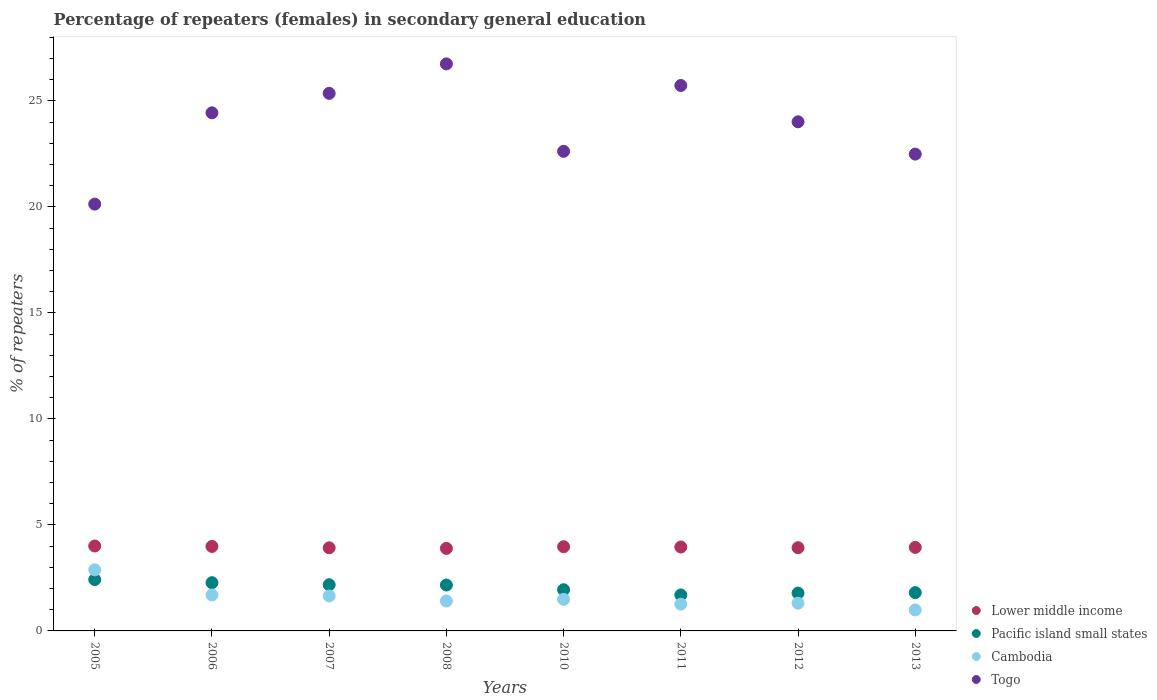How many different coloured dotlines are there?
Provide a short and direct response. 4. What is the percentage of female repeaters in Togo in 2011?
Keep it short and to the point. 25.73. Across all years, what is the maximum percentage of female repeaters in Lower middle income?
Make the answer very short. 4.01. Across all years, what is the minimum percentage of female repeaters in Pacific island small states?
Ensure brevity in your answer.  1.7. What is the total percentage of female repeaters in Lower middle income in the graph?
Your response must be concise. 31.6. What is the difference between the percentage of female repeaters in Togo in 2010 and that in 2011?
Provide a succinct answer. -3.11. What is the difference between the percentage of female repeaters in Cambodia in 2010 and the percentage of female repeaters in Lower middle income in 2012?
Your answer should be very brief. -2.44. What is the average percentage of female repeaters in Pacific island small states per year?
Your answer should be compact. 2.03. In the year 2012, what is the difference between the percentage of female repeaters in Togo and percentage of female repeaters in Pacific island small states?
Give a very brief answer. 22.23. In how many years, is the percentage of female repeaters in Pacific island small states greater than 27 %?
Your answer should be compact. 0. What is the ratio of the percentage of female repeaters in Pacific island small states in 2005 to that in 2010?
Ensure brevity in your answer.  1.25. Is the percentage of female repeaters in Togo in 2005 less than that in 2012?
Give a very brief answer. Yes. Is the difference between the percentage of female repeaters in Togo in 2005 and 2011 greater than the difference between the percentage of female repeaters in Pacific island small states in 2005 and 2011?
Offer a terse response. No. What is the difference between the highest and the second highest percentage of female repeaters in Pacific island small states?
Make the answer very short. 0.15. What is the difference between the highest and the lowest percentage of female repeaters in Lower middle income?
Make the answer very short. 0.11. In how many years, is the percentage of female repeaters in Cambodia greater than the average percentage of female repeaters in Cambodia taken over all years?
Offer a terse response. 3. Is the sum of the percentage of female repeaters in Pacific island small states in 2006 and 2011 greater than the maximum percentage of female repeaters in Cambodia across all years?
Your answer should be very brief. Yes. Is it the case that in every year, the sum of the percentage of female repeaters in Pacific island small states and percentage of female repeaters in Togo  is greater than the sum of percentage of female repeaters in Lower middle income and percentage of female repeaters in Cambodia?
Ensure brevity in your answer.  Yes. Is it the case that in every year, the sum of the percentage of female repeaters in Togo and percentage of female repeaters in Lower middle income  is greater than the percentage of female repeaters in Cambodia?
Provide a short and direct response. Yes. Is the percentage of female repeaters in Lower middle income strictly greater than the percentage of female repeaters in Togo over the years?
Give a very brief answer. No. Are the values on the major ticks of Y-axis written in scientific E-notation?
Your answer should be very brief. No. Does the graph contain any zero values?
Make the answer very short. No. How many legend labels are there?
Offer a very short reply. 4. How are the legend labels stacked?
Give a very brief answer. Vertical. What is the title of the graph?
Offer a very short reply. Percentage of repeaters (females) in secondary general education. What is the label or title of the X-axis?
Keep it short and to the point. Years. What is the label or title of the Y-axis?
Offer a very short reply. % of repeaters. What is the % of repeaters of Lower middle income in 2005?
Your response must be concise. 4.01. What is the % of repeaters of Pacific island small states in 2005?
Provide a short and direct response. 2.42. What is the % of repeaters in Cambodia in 2005?
Ensure brevity in your answer.  2.88. What is the % of repeaters in Togo in 2005?
Ensure brevity in your answer.  20.13. What is the % of repeaters of Lower middle income in 2006?
Your answer should be very brief. 3.99. What is the % of repeaters in Pacific island small states in 2006?
Your response must be concise. 2.28. What is the % of repeaters of Cambodia in 2006?
Offer a very short reply. 1.7. What is the % of repeaters of Togo in 2006?
Ensure brevity in your answer.  24.44. What is the % of repeaters of Lower middle income in 2007?
Your answer should be very brief. 3.92. What is the % of repeaters of Pacific island small states in 2007?
Provide a short and direct response. 2.18. What is the % of repeaters in Cambodia in 2007?
Keep it short and to the point. 1.65. What is the % of repeaters in Togo in 2007?
Provide a short and direct response. 25.36. What is the % of repeaters in Lower middle income in 2008?
Your answer should be very brief. 3.89. What is the % of repeaters in Pacific island small states in 2008?
Provide a succinct answer. 2.16. What is the % of repeaters in Cambodia in 2008?
Ensure brevity in your answer.  1.41. What is the % of repeaters in Togo in 2008?
Offer a terse response. 26.75. What is the % of repeaters in Lower middle income in 2010?
Your response must be concise. 3.97. What is the % of repeaters of Pacific island small states in 2010?
Ensure brevity in your answer.  1.94. What is the % of repeaters in Cambodia in 2010?
Your response must be concise. 1.49. What is the % of repeaters in Togo in 2010?
Your answer should be very brief. 22.62. What is the % of repeaters in Lower middle income in 2011?
Provide a succinct answer. 3.96. What is the % of repeaters of Pacific island small states in 2011?
Give a very brief answer. 1.7. What is the % of repeaters of Cambodia in 2011?
Provide a short and direct response. 1.26. What is the % of repeaters of Togo in 2011?
Your response must be concise. 25.73. What is the % of repeaters in Lower middle income in 2012?
Give a very brief answer. 3.93. What is the % of repeaters of Pacific island small states in 2012?
Your answer should be very brief. 1.79. What is the % of repeaters of Cambodia in 2012?
Make the answer very short. 1.31. What is the % of repeaters in Togo in 2012?
Offer a terse response. 24.02. What is the % of repeaters in Lower middle income in 2013?
Your response must be concise. 3.94. What is the % of repeaters in Pacific island small states in 2013?
Make the answer very short. 1.81. What is the % of repeaters of Cambodia in 2013?
Your answer should be compact. 0.99. What is the % of repeaters in Togo in 2013?
Provide a succinct answer. 22.49. Across all years, what is the maximum % of repeaters in Lower middle income?
Provide a short and direct response. 4.01. Across all years, what is the maximum % of repeaters of Pacific island small states?
Ensure brevity in your answer.  2.42. Across all years, what is the maximum % of repeaters of Cambodia?
Keep it short and to the point. 2.88. Across all years, what is the maximum % of repeaters of Togo?
Provide a succinct answer. 26.75. Across all years, what is the minimum % of repeaters in Lower middle income?
Offer a very short reply. 3.89. Across all years, what is the minimum % of repeaters in Pacific island small states?
Provide a short and direct response. 1.7. Across all years, what is the minimum % of repeaters of Cambodia?
Your response must be concise. 0.99. Across all years, what is the minimum % of repeaters of Togo?
Make the answer very short. 20.13. What is the total % of repeaters of Lower middle income in the graph?
Your response must be concise. 31.6. What is the total % of repeaters in Pacific island small states in the graph?
Offer a terse response. 16.27. What is the total % of repeaters of Cambodia in the graph?
Provide a short and direct response. 12.69. What is the total % of repeaters of Togo in the graph?
Offer a very short reply. 191.55. What is the difference between the % of repeaters in Lower middle income in 2005 and that in 2006?
Your response must be concise. 0.02. What is the difference between the % of repeaters in Pacific island small states in 2005 and that in 2006?
Offer a terse response. 0.15. What is the difference between the % of repeaters of Cambodia in 2005 and that in 2006?
Provide a short and direct response. 1.19. What is the difference between the % of repeaters in Togo in 2005 and that in 2006?
Your answer should be compact. -4.31. What is the difference between the % of repeaters of Lower middle income in 2005 and that in 2007?
Your response must be concise. 0.08. What is the difference between the % of repeaters in Pacific island small states in 2005 and that in 2007?
Provide a succinct answer. 0.24. What is the difference between the % of repeaters of Cambodia in 2005 and that in 2007?
Provide a succinct answer. 1.23. What is the difference between the % of repeaters of Togo in 2005 and that in 2007?
Offer a very short reply. -5.22. What is the difference between the % of repeaters in Lower middle income in 2005 and that in 2008?
Provide a short and direct response. 0.11. What is the difference between the % of repeaters in Pacific island small states in 2005 and that in 2008?
Make the answer very short. 0.26. What is the difference between the % of repeaters of Cambodia in 2005 and that in 2008?
Your answer should be very brief. 1.47. What is the difference between the % of repeaters in Togo in 2005 and that in 2008?
Make the answer very short. -6.61. What is the difference between the % of repeaters of Lower middle income in 2005 and that in 2010?
Provide a succinct answer. 0.03. What is the difference between the % of repeaters in Pacific island small states in 2005 and that in 2010?
Your response must be concise. 0.48. What is the difference between the % of repeaters of Cambodia in 2005 and that in 2010?
Ensure brevity in your answer.  1.39. What is the difference between the % of repeaters of Togo in 2005 and that in 2010?
Ensure brevity in your answer.  -2.49. What is the difference between the % of repeaters in Lower middle income in 2005 and that in 2011?
Make the answer very short. 0.05. What is the difference between the % of repeaters of Pacific island small states in 2005 and that in 2011?
Offer a terse response. 0.73. What is the difference between the % of repeaters in Cambodia in 2005 and that in 2011?
Provide a succinct answer. 1.62. What is the difference between the % of repeaters of Togo in 2005 and that in 2011?
Your answer should be very brief. -5.59. What is the difference between the % of repeaters in Lower middle income in 2005 and that in 2012?
Give a very brief answer. 0.08. What is the difference between the % of repeaters in Pacific island small states in 2005 and that in 2012?
Keep it short and to the point. 0.64. What is the difference between the % of repeaters of Cambodia in 2005 and that in 2012?
Keep it short and to the point. 1.57. What is the difference between the % of repeaters of Togo in 2005 and that in 2012?
Your answer should be compact. -3.88. What is the difference between the % of repeaters in Lower middle income in 2005 and that in 2013?
Give a very brief answer. 0.07. What is the difference between the % of repeaters of Pacific island small states in 2005 and that in 2013?
Ensure brevity in your answer.  0.62. What is the difference between the % of repeaters of Cambodia in 2005 and that in 2013?
Provide a succinct answer. 1.89. What is the difference between the % of repeaters of Togo in 2005 and that in 2013?
Provide a succinct answer. -2.36. What is the difference between the % of repeaters in Lower middle income in 2006 and that in 2007?
Your response must be concise. 0.07. What is the difference between the % of repeaters of Pacific island small states in 2006 and that in 2007?
Give a very brief answer. 0.1. What is the difference between the % of repeaters of Cambodia in 2006 and that in 2007?
Keep it short and to the point. 0.05. What is the difference between the % of repeaters in Togo in 2006 and that in 2007?
Give a very brief answer. -0.92. What is the difference between the % of repeaters in Lower middle income in 2006 and that in 2008?
Provide a short and direct response. 0.09. What is the difference between the % of repeaters of Pacific island small states in 2006 and that in 2008?
Give a very brief answer. 0.11. What is the difference between the % of repeaters in Cambodia in 2006 and that in 2008?
Your answer should be very brief. 0.29. What is the difference between the % of repeaters in Togo in 2006 and that in 2008?
Give a very brief answer. -2.31. What is the difference between the % of repeaters in Lower middle income in 2006 and that in 2010?
Provide a short and direct response. 0.01. What is the difference between the % of repeaters of Pacific island small states in 2006 and that in 2010?
Provide a short and direct response. 0.33. What is the difference between the % of repeaters in Cambodia in 2006 and that in 2010?
Provide a succinct answer. 0.21. What is the difference between the % of repeaters of Togo in 2006 and that in 2010?
Offer a terse response. 1.82. What is the difference between the % of repeaters of Lower middle income in 2006 and that in 2011?
Ensure brevity in your answer.  0.03. What is the difference between the % of repeaters of Pacific island small states in 2006 and that in 2011?
Your answer should be compact. 0.58. What is the difference between the % of repeaters in Cambodia in 2006 and that in 2011?
Your response must be concise. 0.43. What is the difference between the % of repeaters in Togo in 2006 and that in 2011?
Offer a very short reply. -1.29. What is the difference between the % of repeaters of Lower middle income in 2006 and that in 2012?
Provide a succinct answer. 0.06. What is the difference between the % of repeaters in Pacific island small states in 2006 and that in 2012?
Your response must be concise. 0.49. What is the difference between the % of repeaters in Cambodia in 2006 and that in 2012?
Keep it short and to the point. 0.39. What is the difference between the % of repeaters of Togo in 2006 and that in 2012?
Give a very brief answer. 0.42. What is the difference between the % of repeaters of Lower middle income in 2006 and that in 2013?
Provide a succinct answer. 0.05. What is the difference between the % of repeaters of Pacific island small states in 2006 and that in 2013?
Provide a succinct answer. 0.47. What is the difference between the % of repeaters in Cambodia in 2006 and that in 2013?
Make the answer very short. 0.71. What is the difference between the % of repeaters of Togo in 2006 and that in 2013?
Offer a terse response. 1.95. What is the difference between the % of repeaters in Lower middle income in 2007 and that in 2008?
Your answer should be very brief. 0.03. What is the difference between the % of repeaters in Pacific island small states in 2007 and that in 2008?
Give a very brief answer. 0.01. What is the difference between the % of repeaters in Cambodia in 2007 and that in 2008?
Offer a very short reply. 0.24. What is the difference between the % of repeaters of Togo in 2007 and that in 2008?
Give a very brief answer. -1.39. What is the difference between the % of repeaters of Lower middle income in 2007 and that in 2010?
Keep it short and to the point. -0.05. What is the difference between the % of repeaters of Pacific island small states in 2007 and that in 2010?
Offer a very short reply. 0.24. What is the difference between the % of repeaters in Cambodia in 2007 and that in 2010?
Keep it short and to the point. 0.16. What is the difference between the % of repeaters in Togo in 2007 and that in 2010?
Keep it short and to the point. 2.73. What is the difference between the % of repeaters of Lower middle income in 2007 and that in 2011?
Provide a succinct answer. -0.04. What is the difference between the % of repeaters of Pacific island small states in 2007 and that in 2011?
Make the answer very short. 0.48. What is the difference between the % of repeaters in Cambodia in 2007 and that in 2011?
Keep it short and to the point. 0.39. What is the difference between the % of repeaters in Togo in 2007 and that in 2011?
Provide a succinct answer. -0.37. What is the difference between the % of repeaters in Lower middle income in 2007 and that in 2012?
Make the answer very short. -0.01. What is the difference between the % of repeaters of Pacific island small states in 2007 and that in 2012?
Keep it short and to the point. 0.39. What is the difference between the % of repeaters of Cambodia in 2007 and that in 2012?
Provide a short and direct response. 0.34. What is the difference between the % of repeaters of Togo in 2007 and that in 2012?
Offer a terse response. 1.34. What is the difference between the % of repeaters of Lower middle income in 2007 and that in 2013?
Keep it short and to the point. -0.02. What is the difference between the % of repeaters in Pacific island small states in 2007 and that in 2013?
Offer a terse response. 0.37. What is the difference between the % of repeaters of Cambodia in 2007 and that in 2013?
Provide a short and direct response. 0.66. What is the difference between the % of repeaters of Togo in 2007 and that in 2013?
Keep it short and to the point. 2.87. What is the difference between the % of repeaters of Lower middle income in 2008 and that in 2010?
Your answer should be compact. -0.08. What is the difference between the % of repeaters in Pacific island small states in 2008 and that in 2010?
Your response must be concise. 0.22. What is the difference between the % of repeaters of Cambodia in 2008 and that in 2010?
Your answer should be compact. -0.08. What is the difference between the % of repeaters of Togo in 2008 and that in 2010?
Ensure brevity in your answer.  4.12. What is the difference between the % of repeaters of Lower middle income in 2008 and that in 2011?
Ensure brevity in your answer.  -0.07. What is the difference between the % of repeaters in Pacific island small states in 2008 and that in 2011?
Offer a terse response. 0.47. What is the difference between the % of repeaters in Cambodia in 2008 and that in 2011?
Give a very brief answer. 0.15. What is the difference between the % of repeaters in Togo in 2008 and that in 2011?
Provide a short and direct response. 1.02. What is the difference between the % of repeaters in Lower middle income in 2008 and that in 2012?
Provide a succinct answer. -0.03. What is the difference between the % of repeaters of Pacific island small states in 2008 and that in 2012?
Provide a short and direct response. 0.38. What is the difference between the % of repeaters in Cambodia in 2008 and that in 2012?
Make the answer very short. 0.1. What is the difference between the % of repeaters in Togo in 2008 and that in 2012?
Provide a succinct answer. 2.73. What is the difference between the % of repeaters in Lower middle income in 2008 and that in 2013?
Offer a terse response. -0.05. What is the difference between the % of repeaters of Pacific island small states in 2008 and that in 2013?
Offer a terse response. 0.36. What is the difference between the % of repeaters of Cambodia in 2008 and that in 2013?
Your response must be concise. 0.42. What is the difference between the % of repeaters of Togo in 2008 and that in 2013?
Give a very brief answer. 4.26. What is the difference between the % of repeaters of Lower middle income in 2010 and that in 2011?
Your answer should be compact. 0.01. What is the difference between the % of repeaters in Pacific island small states in 2010 and that in 2011?
Provide a short and direct response. 0.25. What is the difference between the % of repeaters of Cambodia in 2010 and that in 2011?
Keep it short and to the point. 0.23. What is the difference between the % of repeaters in Togo in 2010 and that in 2011?
Your response must be concise. -3.11. What is the difference between the % of repeaters of Lower middle income in 2010 and that in 2012?
Your response must be concise. 0.05. What is the difference between the % of repeaters of Pacific island small states in 2010 and that in 2012?
Your answer should be compact. 0.16. What is the difference between the % of repeaters of Cambodia in 2010 and that in 2012?
Offer a very short reply. 0.18. What is the difference between the % of repeaters in Togo in 2010 and that in 2012?
Ensure brevity in your answer.  -1.39. What is the difference between the % of repeaters of Lower middle income in 2010 and that in 2013?
Your answer should be very brief. 0.03. What is the difference between the % of repeaters in Pacific island small states in 2010 and that in 2013?
Make the answer very short. 0.14. What is the difference between the % of repeaters in Cambodia in 2010 and that in 2013?
Give a very brief answer. 0.5. What is the difference between the % of repeaters of Togo in 2010 and that in 2013?
Your response must be concise. 0.13. What is the difference between the % of repeaters in Lower middle income in 2011 and that in 2012?
Offer a terse response. 0.03. What is the difference between the % of repeaters in Pacific island small states in 2011 and that in 2012?
Ensure brevity in your answer.  -0.09. What is the difference between the % of repeaters of Cambodia in 2011 and that in 2012?
Make the answer very short. -0.05. What is the difference between the % of repeaters in Togo in 2011 and that in 2012?
Your response must be concise. 1.71. What is the difference between the % of repeaters in Lower middle income in 2011 and that in 2013?
Your response must be concise. 0.02. What is the difference between the % of repeaters in Pacific island small states in 2011 and that in 2013?
Offer a terse response. -0.11. What is the difference between the % of repeaters in Cambodia in 2011 and that in 2013?
Your answer should be compact. 0.27. What is the difference between the % of repeaters of Togo in 2011 and that in 2013?
Give a very brief answer. 3.24. What is the difference between the % of repeaters of Lower middle income in 2012 and that in 2013?
Keep it short and to the point. -0.01. What is the difference between the % of repeaters of Pacific island small states in 2012 and that in 2013?
Ensure brevity in your answer.  -0.02. What is the difference between the % of repeaters of Cambodia in 2012 and that in 2013?
Your answer should be compact. 0.32. What is the difference between the % of repeaters of Togo in 2012 and that in 2013?
Offer a terse response. 1.52. What is the difference between the % of repeaters of Lower middle income in 2005 and the % of repeaters of Pacific island small states in 2006?
Ensure brevity in your answer.  1.73. What is the difference between the % of repeaters in Lower middle income in 2005 and the % of repeaters in Cambodia in 2006?
Make the answer very short. 2.31. What is the difference between the % of repeaters of Lower middle income in 2005 and the % of repeaters of Togo in 2006?
Give a very brief answer. -20.43. What is the difference between the % of repeaters of Pacific island small states in 2005 and the % of repeaters of Cambodia in 2006?
Offer a terse response. 0.73. What is the difference between the % of repeaters in Pacific island small states in 2005 and the % of repeaters in Togo in 2006?
Offer a terse response. -22.02. What is the difference between the % of repeaters in Cambodia in 2005 and the % of repeaters in Togo in 2006?
Offer a very short reply. -21.56. What is the difference between the % of repeaters of Lower middle income in 2005 and the % of repeaters of Pacific island small states in 2007?
Your answer should be very brief. 1.83. What is the difference between the % of repeaters in Lower middle income in 2005 and the % of repeaters in Cambodia in 2007?
Your response must be concise. 2.36. What is the difference between the % of repeaters in Lower middle income in 2005 and the % of repeaters in Togo in 2007?
Your response must be concise. -21.35. What is the difference between the % of repeaters of Pacific island small states in 2005 and the % of repeaters of Cambodia in 2007?
Ensure brevity in your answer.  0.77. What is the difference between the % of repeaters in Pacific island small states in 2005 and the % of repeaters in Togo in 2007?
Provide a short and direct response. -22.94. What is the difference between the % of repeaters of Cambodia in 2005 and the % of repeaters of Togo in 2007?
Provide a succinct answer. -22.48. What is the difference between the % of repeaters in Lower middle income in 2005 and the % of repeaters in Pacific island small states in 2008?
Keep it short and to the point. 1.84. What is the difference between the % of repeaters of Lower middle income in 2005 and the % of repeaters of Cambodia in 2008?
Provide a succinct answer. 2.59. What is the difference between the % of repeaters in Lower middle income in 2005 and the % of repeaters in Togo in 2008?
Provide a succinct answer. -22.74. What is the difference between the % of repeaters of Pacific island small states in 2005 and the % of repeaters of Cambodia in 2008?
Ensure brevity in your answer.  1.01. What is the difference between the % of repeaters in Pacific island small states in 2005 and the % of repeaters in Togo in 2008?
Offer a very short reply. -24.33. What is the difference between the % of repeaters in Cambodia in 2005 and the % of repeaters in Togo in 2008?
Ensure brevity in your answer.  -23.87. What is the difference between the % of repeaters in Lower middle income in 2005 and the % of repeaters in Pacific island small states in 2010?
Ensure brevity in your answer.  2.06. What is the difference between the % of repeaters of Lower middle income in 2005 and the % of repeaters of Cambodia in 2010?
Your response must be concise. 2.52. What is the difference between the % of repeaters in Lower middle income in 2005 and the % of repeaters in Togo in 2010?
Give a very brief answer. -18.62. What is the difference between the % of repeaters of Pacific island small states in 2005 and the % of repeaters of Cambodia in 2010?
Provide a short and direct response. 0.93. What is the difference between the % of repeaters of Pacific island small states in 2005 and the % of repeaters of Togo in 2010?
Provide a succinct answer. -20.2. What is the difference between the % of repeaters in Cambodia in 2005 and the % of repeaters in Togo in 2010?
Your response must be concise. -19.74. What is the difference between the % of repeaters in Lower middle income in 2005 and the % of repeaters in Pacific island small states in 2011?
Provide a succinct answer. 2.31. What is the difference between the % of repeaters in Lower middle income in 2005 and the % of repeaters in Cambodia in 2011?
Ensure brevity in your answer.  2.74. What is the difference between the % of repeaters in Lower middle income in 2005 and the % of repeaters in Togo in 2011?
Offer a terse response. -21.72. What is the difference between the % of repeaters in Pacific island small states in 2005 and the % of repeaters in Cambodia in 2011?
Give a very brief answer. 1.16. What is the difference between the % of repeaters of Pacific island small states in 2005 and the % of repeaters of Togo in 2011?
Your response must be concise. -23.31. What is the difference between the % of repeaters of Cambodia in 2005 and the % of repeaters of Togo in 2011?
Provide a short and direct response. -22.85. What is the difference between the % of repeaters in Lower middle income in 2005 and the % of repeaters in Pacific island small states in 2012?
Offer a very short reply. 2.22. What is the difference between the % of repeaters of Lower middle income in 2005 and the % of repeaters of Cambodia in 2012?
Ensure brevity in your answer.  2.7. What is the difference between the % of repeaters of Lower middle income in 2005 and the % of repeaters of Togo in 2012?
Ensure brevity in your answer.  -20.01. What is the difference between the % of repeaters of Pacific island small states in 2005 and the % of repeaters of Cambodia in 2012?
Provide a short and direct response. 1.11. What is the difference between the % of repeaters in Pacific island small states in 2005 and the % of repeaters in Togo in 2012?
Ensure brevity in your answer.  -21.59. What is the difference between the % of repeaters in Cambodia in 2005 and the % of repeaters in Togo in 2012?
Ensure brevity in your answer.  -21.14. What is the difference between the % of repeaters in Lower middle income in 2005 and the % of repeaters in Pacific island small states in 2013?
Keep it short and to the point. 2.2. What is the difference between the % of repeaters in Lower middle income in 2005 and the % of repeaters in Cambodia in 2013?
Give a very brief answer. 3.01. What is the difference between the % of repeaters of Lower middle income in 2005 and the % of repeaters of Togo in 2013?
Offer a very short reply. -18.49. What is the difference between the % of repeaters in Pacific island small states in 2005 and the % of repeaters in Cambodia in 2013?
Provide a succinct answer. 1.43. What is the difference between the % of repeaters of Pacific island small states in 2005 and the % of repeaters of Togo in 2013?
Your answer should be very brief. -20.07. What is the difference between the % of repeaters in Cambodia in 2005 and the % of repeaters in Togo in 2013?
Your answer should be very brief. -19.61. What is the difference between the % of repeaters of Lower middle income in 2006 and the % of repeaters of Pacific island small states in 2007?
Keep it short and to the point. 1.81. What is the difference between the % of repeaters in Lower middle income in 2006 and the % of repeaters in Cambodia in 2007?
Your answer should be compact. 2.34. What is the difference between the % of repeaters of Lower middle income in 2006 and the % of repeaters of Togo in 2007?
Provide a short and direct response. -21.37. What is the difference between the % of repeaters of Pacific island small states in 2006 and the % of repeaters of Cambodia in 2007?
Give a very brief answer. 0.63. What is the difference between the % of repeaters in Pacific island small states in 2006 and the % of repeaters in Togo in 2007?
Offer a very short reply. -23.08. What is the difference between the % of repeaters of Cambodia in 2006 and the % of repeaters of Togo in 2007?
Ensure brevity in your answer.  -23.66. What is the difference between the % of repeaters in Lower middle income in 2006 and the % of repeaters in Pacific island small states in 2008?
Offer a terse response. 1.82. What is the difference between the % of repeaters of Lower middle income in 2006 and the % of repeaters of Cambodia in 2008?
Provide a short and direct response. 2.58. What is the difference between the % of repeaters in Lower middle income in 2006 and the % of repeaters in Togo in 2008?
Offer a very short reply. -22.76. What is the difference between the % of repeaters in Pacific island small states in 2006 and the % of repeaters in Cambodia in 2008?
Offer a terse response. 0.86. What is the difference between the % of repeaters in Pacific island small states in 2006 and the % of repeaters in Togo in 2008?
Give a very brief answer. -24.47. What is the difference between the % of repeaters in Cambodia in 2006 and the % of repeaters in Togo in 2008?
Give a very brief answer. -25.05. What is the difference between the % of repeaters of Lower middle income in 2006 and the % of repeaters of Pacific island small states in 2010?
Provide a succinct answer. 2.04. What is the difference between the % of repeaters of Lower middle income in 2006 and the % of repeaters of Cambodia in 2010?
Give a very brief answer. 2.5. What is the difference between the % of repeaters of Lower middle income in 2006 and the % of repeaters of Togo in 2010?
Offer a terse response. -18.64. What is the difference between the % of repeaters in Pacific island small states in 2006 and the % of repeaters in Cambodia in 2010?
Make the answer very short. 0.78. What is the difference between the % of repeaters of Pacific island small states in 2006 and the % of repeaters of Togo in 2010?
Your answer should be compact. -20.35. What is the difference between the % of repeaters in Cambodia in 2006 and the % of repeaters in Togo in 2010?
Make the answer very short. -20.93. What is the difference between the % of repeaters of Lower middle income in 2006 and the % of repeaters of Pacific island small states in 2011?
Ensure brevity in your answer.  2.29. What is the difference between the % of repeaters of Lower middle income in 2006 and the % of repeaters of Cambodia in 2011?
Offer a very short reply. 2.72. What is the difference between the % of repeaters in Lower middle income in 2006 and the % of repeaters in Togo in 2011?
Offer a terse response. -21.74. What is the difference between the % of repeaters in Pacific island small states in 2006 and the % of repeaters in Cambodia in 2011?
Provide a succinct answer. 1.01. What is the difference between the % of repeaters of Pacific island small states in 2006 and the % of repeaters of Togo in 2011?
Offer a terse response. -23.45. What is the difference between the % of repeaters in Cambodia in 2006 and the % of repeaters in Togo in 2011?
Keep it short and to the point. -24.03. What is the difference between the % of repeaters in Lower middle income in 2006 and the % of repeaters in Pacific island small states in 2012?
Provide a short and direct response. 2.2. What is the difference between the % of repeaters of Lower middle income in 2006 and the % of repeaters of Cambodia in 2012?
Your answer should be very brief. 2.68. What is the difference between the % of repeaters in Lower middle income in 2006 and the % of repeaters in Togo in 2012?
Your response must be concise. -20.03. What is the difference between the % of repeaters in Pacific island small states in 2006 and the % of repeaters in Cambodia in 2012?
Make the answer very short. 0.97. What is the difference between the % of repeaters of Pacific island small states in 2006 and the % of repeaters of Togo in 2012?
Your response must be concise. -21.74. What is the difference between the % of repeaters in Cambodia in 2006 and the % of repeaters in Togo in 2012?
Offer a very short reply. -22.32. What is the difference between the % of repeaters in Lower middle income in 2006 and the % of repeaters in Pacific island small states in 2013?
Ensure brevity in your answer.  2.18. What is the difference between the % of repeaters in Lower middle income in 2006 and the % of repeaters in Cambodia in 2013?
Your response must be concise. 3. What is the difference between the % of repeaters in Lower middle income in 2006 and the % of repeaters in Togo in 2013?
Offer a very short reply. -18.51. What is the difference between the % of repeaters in Pacific island small states in 2006 and the % of repeaters in Cambodia in 2013?
Offer a very short reply. 1.28. What is the difference between the % of repeaters of Pacific island small states in 2006 and the % of repeaters of Togo in 2013?
Make the answer very short. -20.22. What is the difference between the % of repeaters of Cambodia in 2006 and the % of repeaters of Togo in 2013?
Your answer should be compact. -20.8. What is the difference between the % of repeaters in Lower middle income in 2007 and the % of repeaters in Pacific island small states in 2008?
Offer a very short reply. 1.76. What is the difference between the % of repeaters of Lower middle income in 2007 and the % of repeaters of Cambodia in 2008?
Provide a succinct answer. 2.51. What is the difference between the % of repeaters of Lower middle income in 2007 and the % of repeaters of Togo in 2008?
Offer a terse response. -22.83. What is the difference between the % of repeaters of Pacific island small states in 2007 and the % of repeaters of Cambodia in 2008?
Provide a succinct answer. 0.77. What is the difference between the % of repeaters of Pacific island small states in 2007 and the % of repeaters of Togo in 2008?
Provide a succinct answer. -24.57. What is the difference between the % of repeaters in Cambodia in 2007 and the % of repeaters in Togo in 2008?
Make the answer very short. -25.1. What is the difference between the % of repeaters in Lower middle income in 2007 and the % of repeaters in Pacific island small states in 2010?
Offer a very short reply. 1.98. What is the difference between the % of repeaters of Lower middle income in 2007 and the % of repeaters of Cambodia in 2010?
Provide a succinct answer. 2.43. What is the difference between the % of repeaters in Lower middle income in 2007 and the % of repeaters in Togo in 2010?
Give a very brief answer. -18.7. What is the difference between the % of repeaters of Pacific island small states in 2007 and the % of repeaters of Cambodia in 2010?
Make the answer very short. 0.69. What is the difference between the % of repeaters of Pacific island small states in 2007 and the % of repeaters of Togo in 2010?
Offer a very short reply. -20.45. What is the difference between the % of repeaters in Cambodia in 2007 and the % of repeaters in Togo in 2010?
Ensure brevity in your answer.  -20.97. What is the difference between the % of repeaters of Lower middle income in 2007 and the % of repeaters of Pacific island small states in 2011?
Offer a very short reply. 2.22. What is the difference between the % of repeaters of Lower middle income in 2007 and the % of repeaters of Cambodia in 2011?
Provide a succinct answer. 2.66. What is the difference between the % of repeaters of Lower middle income in 2007 and the % of repeaters of Togo in 2011?
Your answer should be very brief. -21.81. What is the difference between the % of repeaters in Pacific island small states in 2007 and the % of repeaters in Cambodia in 2011?
Ensure brevity in your answer.  0.92. What is the difference between the % of repeaters in Pacific island small states in 2007 and the % of repeaters in Togo in 2011?
Give a very brief answer. -23.55. What is the difference between the % of repeaters in Cambodia in 2007 and the % of repeaters in Togo in 2011?
Offer a very short reply. -24.08. What is the difference between the % of repeaters in Lower middle income in 2007 and the % of repeaters in Pacific island small states in 2012?
Offer a very short reply. 2.14. What is the difference between the % of repeaters of Lower middle income in 2007 and the % of repeaters of Cambodia in 2012?
Your answer should be very brief. 2.61. What is the difference between the % of repeaters of Lower middle income in 2007 and the % of repeaters of Togo in 2012?
Your answer should be very brief. -20.1. What is the difference between the % of repeaters of Pacific island small states in 2007 and the % of repeaters of Cambodia in 2012?
Your answer should be very brief. 0.87. What is the difference between the % of repeaters of Pacific island small states in 2007 and the % of repeaters of Togo in 2012?
Provide a succinct answer. -21.84. What is the difference between the % of repeaters of Cambodia in 2007 and the % of repeaters of Togo in 2012?
Offer a terse response. -22.37. What is the difference between the % of repeaters in Lower middle income in 2007 and the % of repeaters in Pacific island small states in 2013?
Your answer should be compact. 2.11. What is the difference between the % of repeaters of Lower middle income in 2007 and the % of repeaters of Cambodia in 2013?
Offer a very short reply. 2.93. What is the difference between the % of repeaters in Lower middle income in 2007 and the % of repeaters in Togo in 2013?
Your response must be concise. -18.57. What is the difference between the % of repeaters of Pacific island small states in 2007 and the % of repeaters of Cambodia in 2013?
Your answer should be compact. 1.19. What is the difference between the % of repeaters of Pacific island small states in 2007 and the % of repeaters of Togo in 2013?
Give a very brief answer. -20.31. What is the difference between the % of repeaters of Cambodia in 2007 and the % of repeaters of Togo in 2013?
Your answer should be compact. -20.84. What is the difference between the % of repeaters of Lower middle income in 2008 and the % of repeaters of Pacific island small states in 2010?
Ensure brevity in your answer.  1.95. What is the difference between the % of repeaters of Lower middle income in 2008 and the % of repeaters of Cambodia in 2010?
Provide a short and direct response. 2.4. What is the difference between the % of repeaters in Lower middle income in 2008 and the % of repeaters in Togo in 2010?
Ensure brevity in your answer.  -18.73. What is the difference between the % of repeaters of Pacific island small states in 2008 and the % of repeaters of Cambodia in 2010?
Keep it short and to the point. 0.67. What is the difference between the % of repeaters of Pacific island small states in 2008 and the % of repeaters of Togo in 2010?
Offer a terse response. -20.46. What is the difference between the % of repeaters in Cambodia in 2008 and the % of repeaters in Togo in 2010?
Provide a succinct answer. -21.21. What is the difference between the % of repeaters in Lower middle income in 2008 and the % of repeaters in Pacific island small states in 2011?
Offer a very short reply. 2.2. What is the difference between the % of repeaters of Lower middle income in 2008 and the % of repeaters of Cambodia in 2011?
Provide a succinct answer. 2.63. What is the difference between the % of repeaters in Lower middle income in 2008 and the % of repeaters in Togo in 2011?
Your answer should be compact. -21.84. What is the difference between the % of repeaters in Pacific island small states in 2008 and the % of repeaters in Cambodia in 2011?
Ensure brevity in your answer.  0.9. What is the difference between the % of repeaters in Pacific island small states in 2008 and the % of repeaters in Togo in 2011?
Keep it short and to the point. -23.57. What is the difference between the % of repeaters of Cambodia in 2008 and the % of repeaters of Togo in 2011?
Offer a very short reply. -24.32. What is the difference between the % of repeaters in Lower middle income in 2008 and the % of repeaters in Pacific island small states in 2012?
Keep it short and to the point. 2.11. What is the difference between the % of repeaters in Lower middle income in 2008 and the % of repeaters in Cambodia in 2012?
Ensure brevity in your answer.  2.58. What is the difference between the % of repeaters of Lower middle income in 2008 and the % of repeaters of Togo in 2012?
Provide a succinct answer. -20.13. What is the difference between the % of repeaters of Pacific island small states in 2008 and the % of repeaters of Cambodia in 2012?
Provide a short and direct response. 0.86. What is the difference between the % of repeaters of Pacific island small states in 2008 and the % of repeaters of Togo in 2012?
Give a very brief answer. -21.85. What is the difference between the % of repeaters of Cambodia in 2008 and the % of repeaters of Togo in 2012?
Your answer should be compact. -22.61. What is the difference between the % of repeaters of Lower middle income in 2008 and the % of repeaters of Pacific island small states in 2013?
Your answer should be very brief. 2.09. What is the difference between the % of repeaters in Lower middle income in 2008 and the % of repeaters in Cambodia in 2013?
Your answer should be compact. 2.9. What is the difference between the % of repeaters in Lower middle income in 2008 and the % of repeaters in Togo in 2013?
Give a very brief answer. -18.6. What is the difference between the % of repeaters of Pacific island small states in 2008 and the % of repeaters of Cambodia in 2013?
Ensure brevity in your answer.  1.17. What is the difference between the % of repeaters in Pacific island small states in 2008 and the % of repeaters in Togo in 2013?
Your answer should be very brief. -20.33. What is the difference between the % of repeaters of Cambodia in 2008 and the % of repeaters of Togo in 2013?
Your answer should be compact. -21.08. What is the difference between the % of repeaters in Lower middle income in 2010 and the % of repeaters in Pacific island small states in 2011?
Ensure brevity in your answer.  2.28. What is the difference between the % of repeaters of Lower middle income in 2010 and the % of repeaters of Cambodia in 2011?
Your response must be concise. 2.71. What is the difference between the % of repeaters in Lower middle income in 2010 and the % of repeaters in Togo in 2011?
Ensure brevity in your answer.  -21.76. What is the difference between the % of repeaters of Pacific island small states in 2010 and the % of repeaters of Cambodia in 2011?
Ensure brevity in your answer.  0.68. What is the difference between the % of repeaters of Pacific island small states in 2010 and the % of repeaters of Togo in 2011?
Your response must be concise. -23.79. What is the difference between the % of repeaters in Cambodia in 2010 and the % of repeaters in Togo in 2011?
Give a very brief answer. -24.24. What is the difference between the % of repeaters in Lower middle income in 2010 and the % of repeaters in Pacific island small states in 2012?
Make the answer very short. 2.19. What is the difference between the % of repeaters in Lower middle income in 2010 and the % of repeaters in Cambodia in 2012?
Your answer should be very brief. 2.66. What is the difference between the % of repeaters in Lower middle income in 2010 and the % of repeaters in Togo in 2012?
Make the answer very short. -20.05. What is the difference between the % of repeaters in Pacific island small states in 2010 and the % of repeaters in Cambodia in 2012?
Give a very brief answer. 0.64. What is the difference between the % of repeaters in Pacific island small states in 2010 and the % of repeaters in Togo in 2012?
Give a very brief answer. -22.07. What is the difference between the % of repeaters in Cambodia in 2010 and the % of repeaters in Togo in 2012?
Give a very brief answer. -22.53. What is the difference between the % of repeaters of Lower middle income in 2010 and the % of repeaters of Pacific island small states in 2013?
Your response must be concise. 2.17. What is the difference between the % of repeaters of Lower middle income in 2010 and the % of repeaters of Cambodia in 2013?
Keep it short and to the point. 2.98. What is the difference between the % of repeaters in Lower middle income in 2010 and the % of repeaters in Togo in 2013?
Give a very brief answer. -18.52. What is the difference between the % of repeaters in Pacific island small states in 2010 and the % of repeaters in Cambodia in 2013?
Give a very brief answer. 0.95. What is the difference between the % of repeaters in Pacific island small states in 2010 and the % of repeaters in Togo in 2013?
Keep it short and to the point. -20.55. What is the difference between the % of repeaters of Cambodia in 2010 and the % of repeaters of Togo in 2013?
Make the answer very short. -21. What is the difference between the % of repeaters in Lower middle income in 2011 and the % of repeaters in Pacific island small states in 2012?
Offer a very short reply. 2.17. What is the difference between the % of repeaters in Lower middle income in 2011 and the % of repeaters in Cambodia in 2012?
Give a very brief answer. 2.65. What is the difference between the % of repeaters in Lower middle income in 2011 and the % of repeaters in Togo in 2012?
Your response must be concise. -20.06. What is the difference between the % of repeaters in Pacific island small states in 2011 and the % of repeaters in Cambodia in 2012?
Keep it short and to the point. 0.39. What is the difference between the % of repeaters in Pacific island small states in 2011 and the % of repeaters in Togo in 2012?
Your answer should be compact. -22.32. What is the difference between the % of repeaters in Cambodia in 2011 and the % of repeaters in Togo in 2012?
Provide a succinct answer. -22.75. What is the difference between the % of repeaters of Lower middle income in 2011 and the % of repeaters of Pacific island small states in 2013?
Provide a short and direct response. 2.15. What is the difference between the % of repeaters in Lower middle income in 2011 and the % of repeaters in Cambodia in 2013?
Make the answer very short. 2.97. What is the difference between the % of repeaters in Lower middle income in 2011 and the % of repeaters in Togo in 2013?
Your answer should be very brief. -18.54. What is the difference between the % of repeaters in Pacific island small states in 2011 and the % of repeaters in Cambodia in 2013?
Offer a very short reply. 0.71. What is the difference between the % of repeaters of Pacific island small states in 2011 and the % of repeaters of Togo in 2013?
Offer a terse response. -20.8. What is the difference between the % of repeaters in Cambodia in 2011 and the % of repeaters in Togo in 2013?
Your answer should be very brief. -21.23. What is the difference between the % of repeaters in Lower middle income in 2012 and the % of repeaters in Pacific island small states in 2013?
Give a very brief answer. 2.12. What is the difference between the % of repeaters in Lower middle income in 2012 and the % of repeaters in Cambodia in 2013?
Provide a short and direct response. 2.94. What is the difference between the % of repeaters of Lower middle income in 2012 and the % of repeaters of Togo in 2013?
Offer a terse response. -18.57. What is the difference between the % of repeaters of Pacific island small states in 2012 and the % of repeaters of Cambodia in 2013?
Give a very brief answer. 0.79. What is the difference between the % of repeaters of Pacific island small states in 2012 and the % of repeaters of Togo in 2013?
Provide a short and direct response. -20.71. What is the difference between the % of repeaters of Cambodia in 2012 and the % of repeaters of Togo in 2013?
Give a very brief answer. -21.19. What is the average % of repeaters of Lower middle income per year?
Make the answer very short. 3.95. What is the average % of repeaters in Pacific island small states per year?
Keep it short and to the point. 2.03. What is the average % of repeaters of Cambodia per year?
Keep it short and to the point. 1.59. What is the average % of repeaters of Togo per year?
Your answer should be very brief. 23.94. In the year 2005, what is the difference between the % of repeaters in Lower middle income and % of repeaters in Pacific island small states?
Offer a very short reply. 1.58. In the year 2005, what is the difference between the % of repeaters of Lower middle income and % of repeaters of Cambodia?
Make the answer very short. 1.12. In the year 2005, what is the difference between the % of repeaters in Lower middle income and % of repeaters in Togo?
Provide a short and direct response. -16.13. In the year 2005, what is the difference between the % of repeaters of Pacific island small states and % of repeaters of Cambodia?
Your answer should be compact. -0.46. In the year 2005, what is the difference between the % of repeaters in Pacific island small states and % of repeaters in Togo?
Give a very brief answer. -17.71. In the year 2005, what is the difference between the % of repeaters in Cambodia and % of repeaters in Togo?
Your answer should be very brief. -17.25. In the year 2006, what is the difference between the % of repeaters in Lower middle income and % of repeaters in Pacific island small states?
Provide a short and direct response. 1.71. In the year 2006, what is the difference between the % of repeaters of Lower middle income and % of repeaters of Cambodia?
Your response must be concise. 2.29. In the year 2006, what is the difference between the % of repeaters in Lower middle income and % of repeaters in Togo?
Keep it short and to the point. -20.45. In the year 2006, what is the difference between the % of repeaters of Pacific island small states and % of repeaters of Cambodia?
Offer a terse response. 0.58. In the year 2006, what is the difference between the % of repeaters of Pacific island small states and % of repeaters of Togo?
Give a very brief answer. -22.16. In the year 2006, what is the difference between the % of repeaters in Cambodia and % of repeaters in Togo?
Make the answer very short. -22.74. In the year 2007, what is the difference between the % of repeaters of Lower middle income and % of repeaters of Pacific island small states?
Provide a short and direct response. 1.74. In the year 2007, what is the difference between the % of repeaters in Lower middle income and % of repeaters in Cambodia?
Ensure brevity in your answer.  2.27. In the year 2007, what is the difference between the % of repeaters in Lower middle income and % of repeaters in Togo?
Ensure brevity in your answer.  -21.44. In the year 2007, what is the difference between the % of repeaters of Pacific island small states and % of repeaters of Cambodia?
Your answer should be compact. 0.53. In the year 2007, what is the difference between the % of repeaters of Pacific island small states and % of repeaters of Togo?
Provide a short and direct response. -23.18. In the year 2007, what is the difference between the % of repeaters in Cambodia and % of repeaters in Togo?
Make the answer very short. -23.71. In the year 2008, what is the difference between the % of repeaters of Lower middle income and % of repeaters of Pacific island small states?
Provide a short and direct response. 1.73. In the year 2008, what is the difference between the % of repeaters in Lower middle income and % of repeaters in Cambodia?
Your answer should be compact. 2.48. In the year 2008, what is the difference between the % of repeaters of Lower middle income and % of repeaters of Togo?
Your answer should be compact. -22.86. In the year 2008, what is the difference between the % of repeaters in Pacific island small states and % of repeaters in Cambodia?
Your response must be concise. 0.75. In the year 2008, what is the difference between the % of repeaters in Pacific island small states and % of repeaters in Togo?
Make the answer very short. -24.58. In the year 2008, what is the difference between the % of repeaters in Cambodia and % of repeaters in Togo?
Provide a succinct answer. -25.34. In the year 2010, what is the difference between the % of repeaters in Lower middle income and % of repeaters in Pacific island small states?
Make the answer very short. 2.03. In the year 2010, what is the difference between the % of repeaters in Lower middle income and % of repeaters in Cambodia?
Provide a succinct answer. 2.48. In the year 2010, what is the difference between the % of repeaters in Lower middle income and % of repeaters in Togo?
Your response must be concise. -18.65. In the year 2010, what is the difference between the % of repeaters in Pacific island small states and % of repeaters in Cambodia?
Provide a short and direct response. 0.45. In the year 2010, what is the difference between the % of repeaters of Pacific island small states and % of repeaters of Togo?
Keep it short and to the point. -20.68. In the year 2010, what is the difference between the % of repeaters of Cambodia and % of repeaters of Togo?
Offer a terse response. -21.13. In the year 2011, what is the difference between the % of repeaters of Lower middle income and % of repeaters of Pacific island small states?
Your answer should be compact. 2.26. In the year 2011, what is the difference between the % of repeaters in Lower middle income and % of repeaters in Cambodia?
Offer a very short reply. 2.7. In the year 2011, what is the difference between the % of repeaters in Lower middle income and % of repeaters in Togo?
Provide a succinct answer. -21.77. In the year 2011, what is the difference between the % of repeaters of Pacific island small states and % of repeaters of Cambodia?
Give a very brief answer. 0.43. In the year 2011, what is the difference between the % of repeaters of Pacific island small states and % of repeaters of Togo?
Your response must be concise. -24.03. In the year 2011, what is the difference between the % of repeaters in Cambodia and % of repeaters in Togo?
Provide a succinct answer. -24.47. In the year 2012, what is the difference between the % of repeaters of Lower middle income and % of repeaters of Pacific island small states?
Keep it short and to the point. 2.14. In the year 2012, what is the difference between the % of repeaters in Lower middle income and % of repeaters in Cambodia?
Make the answer very short. 2.62. In the year 2012, what is the difference between the % of repeaters of Lower middle income and % of repeaters of Togo?
Your answer should be compact. -20.09. In the year 2012, what is the difference between the % of repeaters of Pacific island small states and % of repeaters of Cambodia?
Give a very brief answer. 0.48. In the year 2012, what is the difference between the % of repeaters in Pacific island small states and % of repeaters in Togo?
Provide a short and direct response. -22.23. In the year 2012, what is the difference between the % of repeaters of Cambodia and % of repeaters of Togo?
Keep it short and to the point. -22.71. In the year 2013, what is the difference between the % of repeaters of Lower middle income and % of repeaters of Pacific island small states?
Offer a terse response. 2.13. In the year 2013, what is the difference between the % of repeaters of Lower middle income and % of repeaters of Cambodia?
Provide a succinct answer. 2.95. In the year 2013, what is the difference between the % of repeaters in Lower middle income and % of repeaters in Togo?
Ensure brevity in your answer.  -18.55. In the year 2013, what is the difference between the % of repeaters of Pacific island small states and % of repeaters of Cambodia?
Provide a succinct answer. 0.82. In the year 2013, what is the difference between the % of repeaters of Pacific island small states and % of repeaters of Togo?
Your response must be concise. -20.69. In the year 2013, what is the difference between the % of repeaters in Cambodia and % of repeaters in Togo?
Keep it short and to the point. -21.5. What is the ratio of the % of repeaters of Lower middle income in 2005 to that in 2006?
Give a very brief answer. 1. What is the ratio of the % of repeaters of Pacific island small states in 2005 to that in 2006?
Your answer should be compact. 1.06. What is the ratio of the % of repeaters in Cambodia in 2005 to that in 2006?
Give a very brief answer. 1.7. What is the ratio of the % of repeaters in Togo in 2005 to that in 2006?
Offer a very short reply. 0.82. What is the ratio of the % of repeaters in Lower middle income in 2005 to that in 2007?
Offer a terse response. 1.02. What is the ratio of the % of repeaters in Pacific island small states in 2005 to that in 2007?
Give a very brief answer. 1.11. What is the ratio of the % of repeaters in Cambodia in 2005 to that in 2007?
Your response must be concise. 1.75. What is the ratio of the % of repeaters of Togo in 2005 to that in 2007?
Ensure brevity in your answer.  0.79. What is the ratio of the % of repeaters in Lower middle income in 2005 to that in 2008?
Provide a short and direct response. 1.03. What is the ratio of the % of repeaters in Pacific island small states in 2005 to that in 2008?
Keep it short and to the point. 1.12. What is the ratio of the % of repeaters in Cambodia in 2005 to that in 2008?
Offer a very short reply. 2.04. What is the ratio of the % of repeaters in Togo in 2005 to that in 2008?
Your answer should be compact. 0.75. What is the ratio of the % of repeaters in Lower middle income in 2005 to that in 2010?
Make the answer very short. 1.01. What is the ratio of the % of repeaters in Pacific island small states in 2005 to that in 2010?
Your answer should be very brief. 1.25. What is the ratio of the % of repeaters of Cambodia in 2005 to that in 2010?
Provide a succinct answer. 1.93. What is the ratio of the % of repeaters of Togo in 2005 to that in 2010?
Your response must be concise. 0.89. What is the ratio of the % of repeaters of Pacific island small states in 2005 to that in 2011?
Your answer should be compact. 1.43. What is the ratio of the % of repeaters in Cambodia in 2005 to that in 2011?
Offer a terse response. 2.28. What is the ratio of the % of repeaters in Togo in 2005 to that in 2011?
Provide a succinct answer. 0.78. What is the ratio of the % of repeaters in Lower middle income in 2005 to that in 2012?
Offer a very short reply. 1.02. What is the ratio of the % of repeaters in Pacific island small states in 2005 to that in 2012?
Your answer should be very brief. 1.36. What is the ratio of the % of repeaters in Cambodia in 2005 to that in 2012?
Offer a very short reply. 2.2. What is the ratio of the % of repeaters of Togo in 2005 to that in 2012?
Offer a terse response. 0.84. What is the ratio of the % of repeaters of Lower middle income in 2005 to that in 2013?
Provide a short and direct response. 1.02. What is the ratio of the % of repeaters of Pacific island small states in 2005 to that in 2013?
Your answer should be very brief. 1.34. What is the ratio of the % of repeaters in Cambodia in 2005 to that in 2013?
Your answer should be very brief. 2.91. What is the ratio of the % of repeaters of Togo in 2005 to that in 2013?
Your answer should be very brief. 0.9. What is the ratio of the % of repeaters in Lower middle income in 2006 to that in 2007?
Give a very brief answer. 1.02. What is the ratio of the % of repeaters of Pacific island small states in 2006 to that in 2007?
Keep it short and to the point. 1.04. What is the ratio of the % of repeaters in Cambodia in 2006 to that in 2007?
Provide a succinct answer. 1.03. What is the ratio of the % of repeaters in Togo in 2006 to that in 2007?
Offer a very short reply. 0.96. What is the ratio of the % of repeaters in Lower middle income in 2006 to that in 2008?
Offer a terse response. 1.02. What is the ratio of the % of repeaters of Pacific island small states in 2006 to that in 2008?
Ensure brevity in your answer.  1.05. What is the ratio of the % of repeaters of Cambodia in 2006 to that in 2008?
Give a very brief answer. 1.2. What is the ratio of the % of repeaters in Togo in 2006 to that in 2008?
Your response must be concise. 0.91. What is the ratio of the % of repeaters of Lower middle income in 2006 to that in 2010?
Ensure brevity in your answer.  1. What is the ratio of the % of repeaters of Pacific island small states in 2006 to that in 2010?
Your answer should be compact. 1.17. What is the ratio of the % of repeaters of Cambodia in 2006 to that in 2010?
Give a very brief answer. 1.14. What is the ratio of the % of repeaters in Togo in 2006 to that in 2010?
Make the answer very short. 1.08. What is the ratio of the % of repeaters in Pacific island small states in 2006 to that in 2011?
Provide a succinct answer. 1.34. What is the ratio of the % of repeaters of Cambodia in 2006 to that in 2011?
Provide a succinct answer. 1.34. What is the ratio of the % of repeaters in Togo in 2006 to that in 2011?
Make the answer very short. 0.95. What is the ratio of the % of repeaters of Lower middle income in 2006 to that in 2012?
Your answer should be very brief. 1.02. What is the ratio of the % of repeaters in Pacific island small states in 2006 to that in 2012?
Give a very brief answer. 1.27. What is the ratio of the % of repeaters of Cambodia in 2006 to that in 2012?
Provide a succinct answer. 1.3. What is the ratio of the % of repeaters in Togo in 2006 to that in 2012?
Make the answer very short. 1.02. What is the ratio of the % of repeaters of Lower middle income in 2006 to that in 2013?
Your answer should be compact. 1.01. What is the ratio of the % of repeaters of Pacific island small states in 2006 to that in 2013?
Ensure brevity in your answer.  1.26. What is the ratio of the % of repeaters in Cambodia in 2006 to that in 2013?
Offer a very short reply. 1.71. What is the ratio of the % of repeaters of Togo in 2006 to that in 2013?
Make the answer very short. 1.09. What is the ratio of the % of repeaters in Lower middle income in 2007 to that in 2008?
Your answer should be very brief. 1.01. What is the ratio of the % of repeaters of Pacific island small states in 2007 to that in 2008?
Provide a succinct answer. 1.01. What is the ratio of the % of repeaters in Cambodia in 2007 to that in 2008?
Provide a succinct answer. 1.17. What is the ratio of the % of repeaters of Togo in 2007 to that in 2008?
Ensure brevity in your answer.  0.95. What is the ratio of the % of repeaters in Lower middle income in 2007 to that in 2010?
Provide a succinct answer. 0.99. What is the ratio of the % of repeaters in Pacific island small states in 2007 to that in 2010?
Offer a very short reply. 1.12. What is the ratio of the % of repeaters in Cambodia in 2007 to that in 2010?
Ensure brevity in your answer.  1.11. What is the ratio of the % of repeaters of Togo in 2007 to that in 2010?
Provide a short and direct response. 1.12. What is the ratio of the % of repeaters of Lower middle income in 2007 to that in 2011?
Ensure brevity in your answer.  0.99. What is the ratio of the % of repeaters of Pacific island small states in 2007 to that in 2011?
Your answer should be compact. 1.28. What is the ratio of the % of repeaters in Cambodia in 2007 to that in 2011?
Make the answer very short. 1.31. What is the ratio of the % of repeaters in Togo in 2007 to that in 2011?
Your answer should be very brief. 0.99. What is the ratio of the % of repeaters of Lower middle income in 2007 to that in 2012?
Offer a very short reply. 1. What is the ratio of the % of repeaters of Pacific island small states in 2007 to that in 2012?
Ensure brevity in your answer.  1.22. What is the ratio of the % of repeaters in Cambodia in 2007 to that in 2012?
Offer a terse response. 1.26. What is the ratio of the % of repeaters in Togo in 2007 to that in 2012?
Give a very brief answer. 1.06. What is the ratio of the % of repeaters in Lower middle income in 2007 to that in 2013?
Your answer should be compact. 1. What is the ratio of the % of repeaters in Pacific island small states in 2007 to that in 2013?
Your answer should be very brief. 1.21. What is the ratio of the % of repeaters in Cambodia in 2007 to that in 2013?
Your answer should be compact. 1.67. What is the ratio of the % of repeaters in Togo in 2007 to that in 2013?
Make the answer very short. 1.13. What is the ratio of the % of repeaters of Lower middle income in 2008 to that in 2010?
Provide a succinct answer. 0.98. What is the ratio of the % of repeaters of Pacific island small states in 2008 to that in 2010?
Make the answer very short. 1.11. What is the ratio of the % of repeaters of Cambodia in 2008 to that in 2010?
Provide a short and direct response. 0.95. What is the ratio of the % of repeaters of Togo in 2008 to that in 2010?
Offer a very short reply. 1.18. What is the ratio of the % of repeaters in Lower middle income in 2008 to that in 2011?
Your response must be concise. 0.98. What is the ratio of the % of repeaters of Pacific island small states in 2008 to that in 2011?
Give a very brief answer. 1.28. What is the ratio of the % of repeaters in Cambodia in 2008 to that in 2011?
Offer a very short reply. 1.12. What is the ratio of the % of repeaters of Togo in 2008 to that in 2011?
Provide a succinct answer. 1.04. What is the ratio of the % of repeaters in Lower middle income in 2008 to that in 2012?
Provide a succinct answer. 0.99. What is the ratio of the % of repeaters in Pacific island small states in 2008 to that in 2012?
Offer a very short reply. 1.21. What is the ratio of the % of repeaters of Cambodia in 2008 to that in 2012?
Your response must be concise. 1.08. What is the ratio of the % of repeaters in Togo in 2008 to that in 2012?
Offer a very short reply. 1.11. What is the ratio of the % of repeaters in Lower middle income in 2008 to that in 2013?
Give a very brief answer. 0.99. What is the ratio of the % of repeaters in Pacific island small states in 2008 to that in 2013?
Ensure brevity in your answer.  1.2. What is the ratio of the % of repeaters in Cambodia in 2008 to that in 2013?
Offer a terse response. 1.42. What is the ratio of the % of repeaters in Togo in 2008 to that in 2013?
Ensure brevity in your answer.  1.19. What is the ratio of the % of repeaters of Pacific island small states in 2010 to that in 2011?
Provide a short and direct response. 1.15. What is the ratio of the % of repeaters of Cambodia in 2010 to that in 2011?
Your answer should be compact. 1.18. What is the ratio of the % of repeaters in Togo in 2010 to that in 2011?
Offer a very short reply. 0.88. What is the ratio of the % of repeaters in Lower middle income in 2010 to that in 2012?
Your answer should be compact. 1.01. What is the ratio of the % of repeaters in Pacific island small states in 2010 to that in 2012?
Your response must be concise. 1.09. What is the ratio of the % of repeaters in Cambodia in 2010 to that in 2012?
Your answer should be compact. 1.14. What is the ratio of the % of repeaters in Togo in 2010 to that in 2012?
Offer a terse response. 0.94. What is the ratio of the % of repeaters in Lower middle income in 2010 to that in 2013?
Give a very brief answer. 1.01. What is the ratio of the % of repeaters of Pacific island small states in 2010 to that in 2013?
Offer a terse response. 1.08. What is the ratio of the % of repeaters in Cambodia in 2010 to that in 2013?
Your response must be concise. 1.5. What is the ratio of the % of repeaters of Togo in 2010 to that in 2013?
Your answer should be compact. 1.01. What is the ratio of the % of repeaters in Lower middle income in 2011 to that in 2012?
Offer a terse response. 1.01. What is the ratio of the % of repeaters of Pacific island small states in 2011 to that in 2012?
Give a very brief answer. 0.95. What is the ratio of the % of repeaters in Cambodia in 2011 to that in 2012?
Ensure brevity in your answer.  0.97. What is the ratio of the % of repeaters of Togo in 2011 to that in 2012?
Offer a terse response. 1.07. What is the ratio of the % of repeaters in Pacific island small states in 2011 to that in 2013?
Your answer should be compact. 0.94. What is the ratio of the % of repeaters of Cambodia in 2011 to that in 2013?
Your answer should be compact. 1.27. What is the ratio of the % of repeaters of Togo in 2011 to that in 2013?
Your response must be concise. 1.14. What is the ratio of the % of repeaters of Pacific island small states in 2012 to that in 2013?
Offer a terse response. 0.99. What is the ratio of the % of repeaters of Cambodia in 2012 to that in 2013?
Provide a short and direct response. 1.32. What is the ratio of the % of repeaters of Togo in 2012 to that in 2013?
Ensure brevity in your answer.  1.07. What is the difference between the highest and the second highest % of repeaters in Lower middle income?
Offer a terse response. 0.02. What is the difference between the highest and the second highest % of repeaters of Pacific island small states?
Ensure brevity in your answer.  0.15. What is the difference between the highest and the second highest % of repeaters in Cambodia?
Provide a short and direct response. 1.19. What is the difference between the highest and the second highest % of repeaters in Togo?
Ensure brevity in your answer.  1.02. What is the difference between the highest and the lowest % of repeaters of Lower middle income?
Provide a succinct answer. 0.11. What is the difference between the highest and the lowest % of repeaters of Pacific island small states?
Ensure brevity in your answer.  0.73. What is the difference between the highest and the lowest % of repeaters in Cambodia?
Give a very brief answer. 1.89. What is the difference between the highest and the lowest % of repeaters in Togo?
Ensure brevity in your answer.  6.61. 